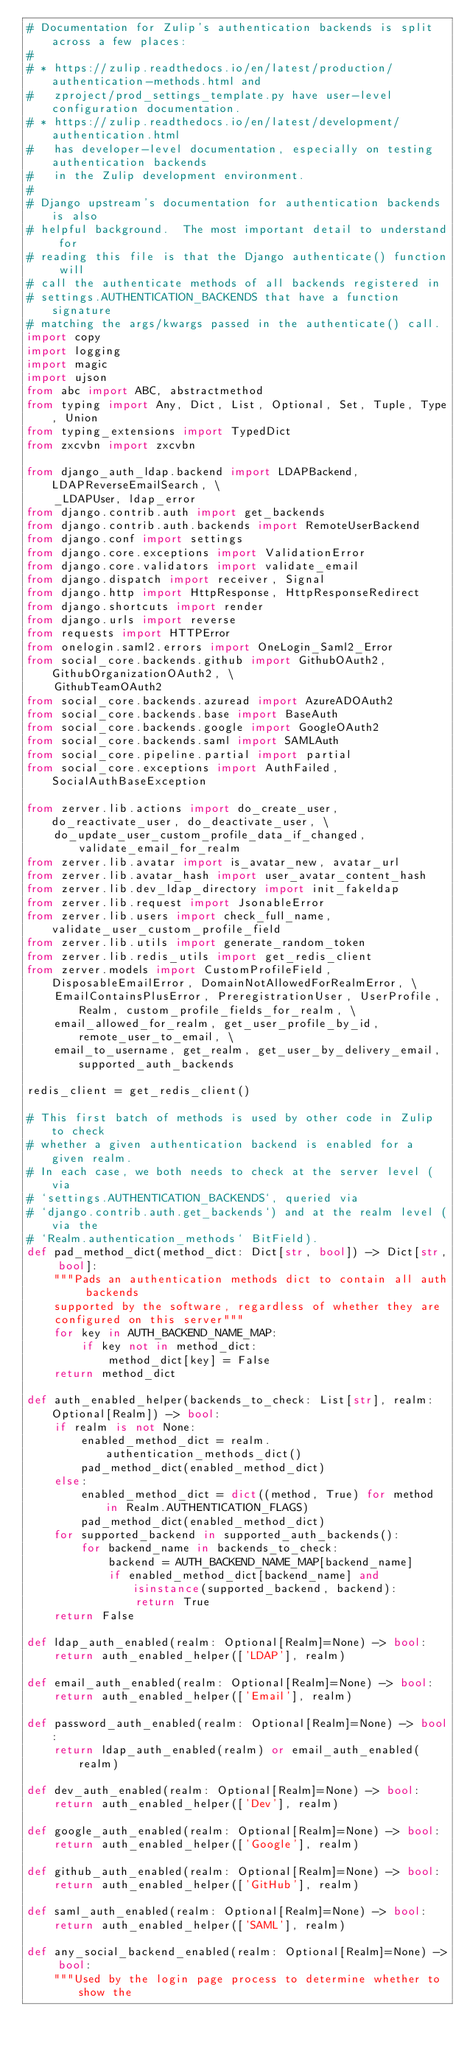<code> <loc_0><loc_0><loc_500><loc_500><_Python_># Documentation for Zulip's authentication backends is split across a few places:
#
# * https://zulip.readthedocs.io/en/latest/production/authentication-methods.html and
#   zproject/prod_settings_template.py have user-level configuration documentation.
# * https://zulip.readthedocs.io/en/latest/development/authentication.html
#   has developer-level documentation, especially on testing authentication backends
#   in the Zulip development environment.
#
# Django upstream's documentation for authentication backends is also
# helpful background.  The most important detail to understand for
# reading this file is that the Django authenticate() function will
# call the authenticate methods of all backends registered in
# settings.AUTHENTICATION_BACKENDS that have a function signature
# matching the args/kwargs passed in the authenticate() call.
import copy
import logging
import magic
import ujson
from abc import ABC, abstractmethod
from typing import Any, Dict, List, Optional, Set, Tuple, Type, Union
from typing_extensions import TypedDict
from zxcvbn import zxcvbn

from django_auth_ldap.backend import LDAPBackend, LDAPReverseEmailSearch, \
    _LDAPUser, ldap_error
from django.contrib.auth import get_backends
from django.contrib.auth.backends import RemoteUserBackend
from django.conf import settings
from django.core.exceptions import ValidationError
from django.core.validators import validate_email
from django.dispatch import receiver, Signal
from django.http import HttpResponse, HttpResponseRedirect
from django.shortcuts import render
from django.urls import reverse
from requests import HTTPError
from onelogin.saml2.errors import OneLogin_Saml2_Error
from social_core.backends.github import GithubOAuth2, GithubOrganizationOAuth2, \
    GithubTeamOAuth2
from social_core.backends.azuread import AzureADOAuth2
from social_core.backends.base import BaseAuth
from social_core.backends.google import GoogleOAuth2
from social_core.backends.saml import SAMLAuth
from social_core.pipeline.partial import partial
from social_core.exceptions import AuthFailed, SocialAuthBaseException

from zerver.lib.actions import do_create_user, do_reactivate_user, do_deactivate_user, \
    do_update_user_custom_profile_data_if_changed, validate_email_for_realm
from zerver.lib.avatar import is_avatar_new, avatar_url
from zerver.lib.avatar_hash import user_avatar_content_hash
from zerver.lib.dev_ldap_directory import init_fakeldap
from zerver.lib.request import JsonableError
from zerver.lib.users import check_full_name, validate_user_custom_profile_field
from zerver.lib.utils import generate_random_token
from zerver.lib.redis_utils import get_redis_client
from zerver.models import CustomProfileField, DisposableEmailError, DomainNotAllowedForRealmError, \
    EmailContainsPlusError, PreregistrationUser, UserProfile, Realm, custom_profile_fields_for_realm, \
    email_allowed_for_realm, get_user_profile_by_id, remote_user_to_email, \
    email_to_username, get_realm, get_user_by_delivery_email, supported_auth_backends

redis_client = get_redis_client()

# This first batch of methods is used by other code in Zulip to check
# whether a given authentication backend is enabled for a given realm.
# In each case, we both needs to check at the server level (via
# `settings.AUTHENTICATION_BACKENDS`, queried via
# `django.contrib.auth.get_backends`) and at the realm level (via the
# `Realm.authentication_methods` BitField).
def pad_method_dict(method_dict: Dict[str, bool]) -> Dict[str, bool]:
    """Pads an authentication methods dict to contain all auth backends
    supported by the software, regardless of whether they are
    configured on this server"""
    for key in AUTH_BACKEND_NAME_MAP:
        if key not in method_dict:
            method_dict[key] = False
    return method_dict

def auth_enabled_helper(backends_to_check: List[str], realm: Optional[Realm]) -> bool:
    if realm is not None:
        enabled_method_dict = realm.authentication_methods_dict()
        pad_method_dict(enabled_method_dict)
    else:
        enabled_method_dict = dict((method, True) for method in Realm.AUTHENTICATION_FLAGS)
        pad_method_dict(enabled_method_dict)
    for supported_backend in supported_auth_backends():
        for backend_name in backends_to_check:
            backend = AUTH_BACKEND_NAME_MAP[backend_name]
            if enabled_method_dict[backend_name] and isinstance(supported_backend, backend):
                return True
    return False

def ldap_auth_enabled(realm: Optional[Realm]=None) -> bool:
    return auth_enabled_helper(['LDAP'], realm)

def email_auth_enabled(realm: Optional[Realm]=None) -> bool:
    return auth_enabled_helper(['Email'], realm)

def password_auth_enabled(realm: Optional[Realm]=None) -> bool:
    return ldap_auth_enabled(realm) or email_auth_enabled(realm)

def dev_auth_enabled(realm: Optional[Realm]=None) -> bool:
    return auth_enabled_helper(['Dev'], realm)

def google_auth_enabled(realm: Optional[Realm]=None) -> bool:
    return auth_enabled_helper(['Google'], realm)

def github_auth_enabled(realm: Optional[Realm]=None) -> bool:
    return auth_enabled_helper(['GitHub'], realm)

def saml_auth_enabled(realm: Optional[Realm]=None) -> bool:
    return auth_enabled_helper(['SAML'], realm)

def any_social_backend_enabled(realm: Optional[Realm]=None) -> bool:
    """Used by the login page process to determine whether to show the</code> 